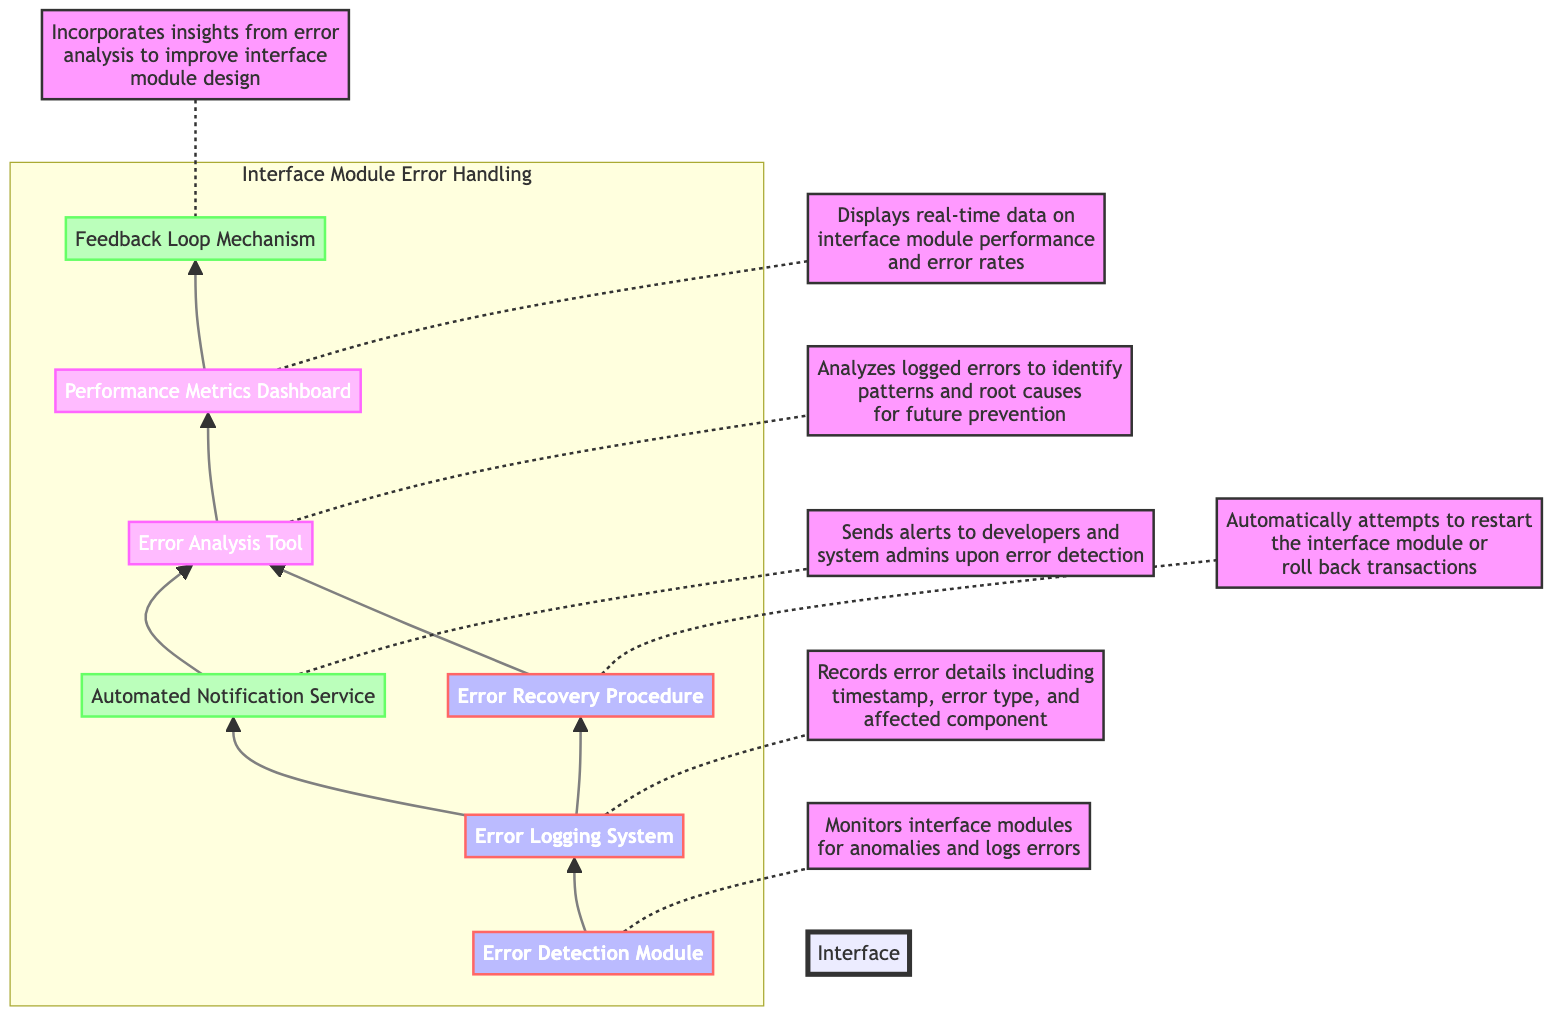What is the first module in the error handling process? The diagram shows that the first module is the "Error Detection Module," which initiates the error handling process by monitoring for anomalies.
Answer: Error Detection Module How many main components are involved in the error handling process? Counting the nodes in the diagram, there are seven main components: Error Detection Module, Error Logging System, Automated Notification Service, Error Recovery Procedure, Error Analysis Tool, Performance Metrics Dashboard, and Feedback Loop Mechanism.
Answer: Seven Which component sends alerts to developers and admins? According to the diagram, the "Automated Notification Service" is responsible for sending alerts regarding error detections.
Answer: Automated Notification Service What is the relationship between the Error Logging System and the Automated Notification Service? The diagram depicts a direct connection from the "Error Logging System" to the "Automated Notification Service," indicating that once an error is logged, an alert is sent out.
Answer: Direct connection What happens after errors are logged? After logging the errors, the next components are both the "Automated Notification Service" and the "Error Recovery Procedure," meaning that alerts are sent and recovery actions are attempted simultaneously.
Answer: Automated Notification Service and Error Recovery Procedure Which component analyzes logged errors? The "Error Analysis Tool" is specifically designated in the diagram as the component that analyzes the logged errors to identify patterns and root causes for future prevention.
Answer: Error Analysis Tool How does the Feedback Loop Mechanism improve system design? The diagram indicates that the "Feedback Loop Mechanism" incorporates insights gained from the "Error Analysis Tool," which helps to inform improvements in interface module design based on error patterns observed.
Answer: Incorporates insights from Error Analysis Tool What is displayed on the Performance Metrics Dashboard? The "Performance Metrics Dashboard" shows real-time data regarding the performance and error rates of the interface modules, providing insight into operational efficiency.
Answer: Real-time data on performance and error rates Which component attempts to restart the interface module? The diagram specifies that the "Error Recovery Procedure" automatically attempts to restart the interface module or roll back transactions when an error is detected.
Answer: Error Recovery Procedure 